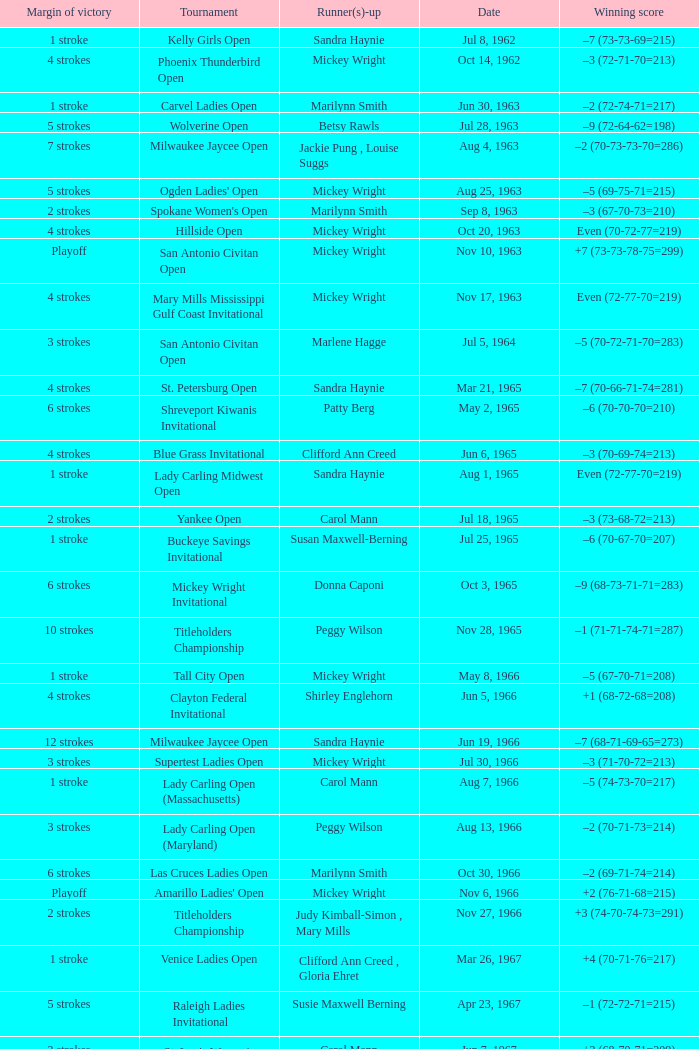What was the margin of victory on Apr 23, 1967? 5 strokes. 